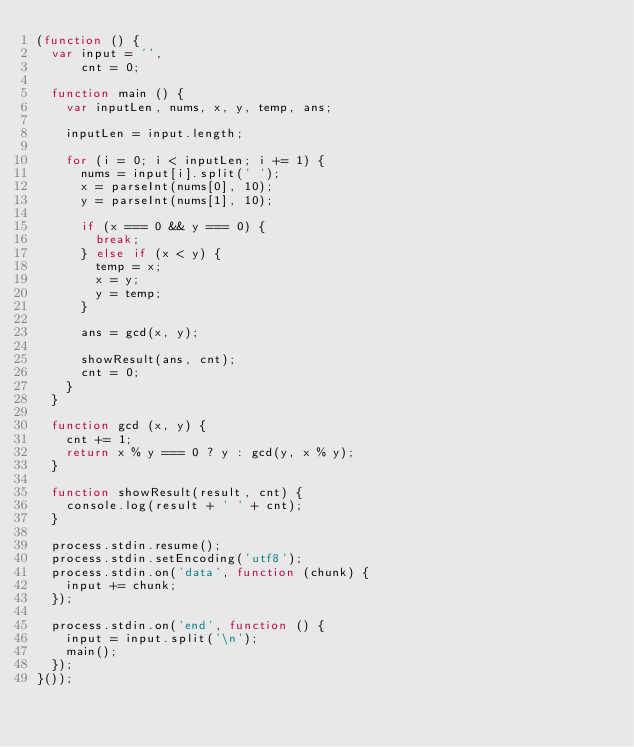<code> <loc_0><loc_0><loc_500><loc_500><_JavaScript_>(function () {
  var input = '',
      cnt = 0;

  function main () {
    var inputLen, nums, x, y, temp, ans;

    inputLen = input.length;
    
    for (i = 0; i < inputLen; i += 1) {
      nums = input[i].split(' ');
      x = parseInt(nums[0], 10);
      y = parseInt(nums[1], 10);

      if (x === 0 && y === 0) {
        break;
      } else if (x < y) {
        temp = x;
        x = y;
        y = temp;
      }

      ans = gcd(x, y);

      showResult(ans, cnt);
      cnt = 0;
    }
  }

  function gcd (x, y) {
    cnt += 1;
    return x % y === 0 ? y : gcd(y, x % y);
  }

  function showResult(result, cnt) {
    console.log(result + ' ' + cnt);
  }

  process.stdin.resume();
  process.stdin.setEncoding('utf8');
  process.stdin.on('data', function (chunk) {
    input += chunk;
  });

  process.stdin.on('end', function () {
    input = input.split('\n');
    main();
  });
}());</code> 